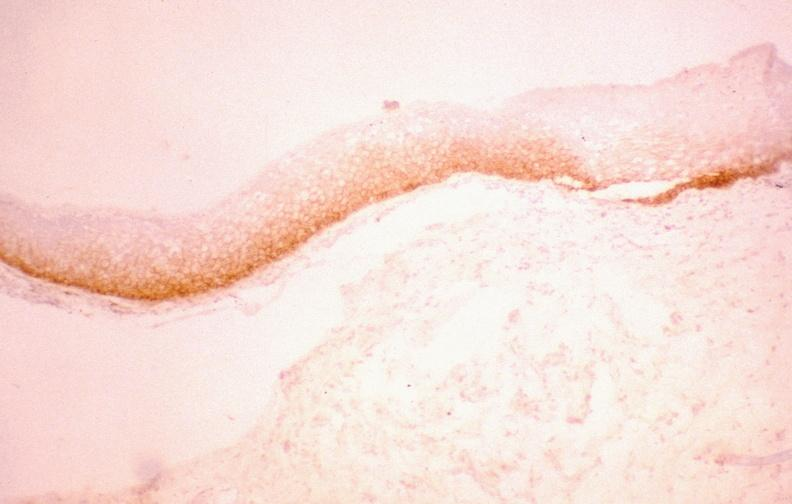what is present?
Answer the question using a single word or phrase. Gastrointestinal 